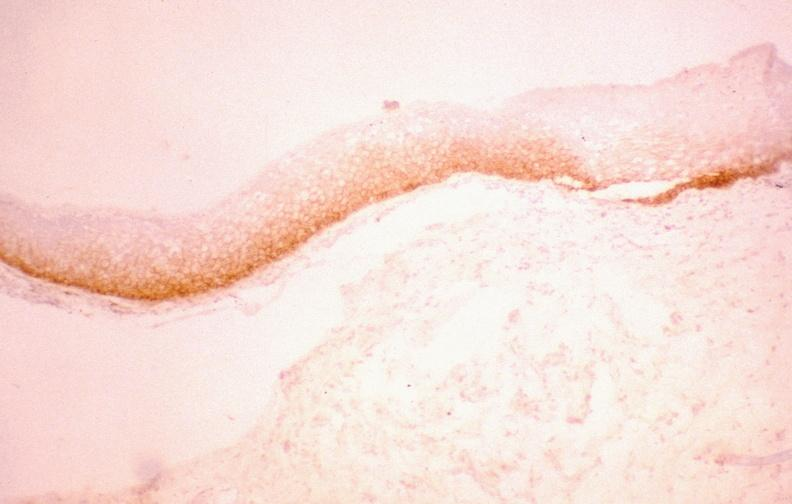what is present?
Answer the question using a single word or phrase. Gastrointestinal 